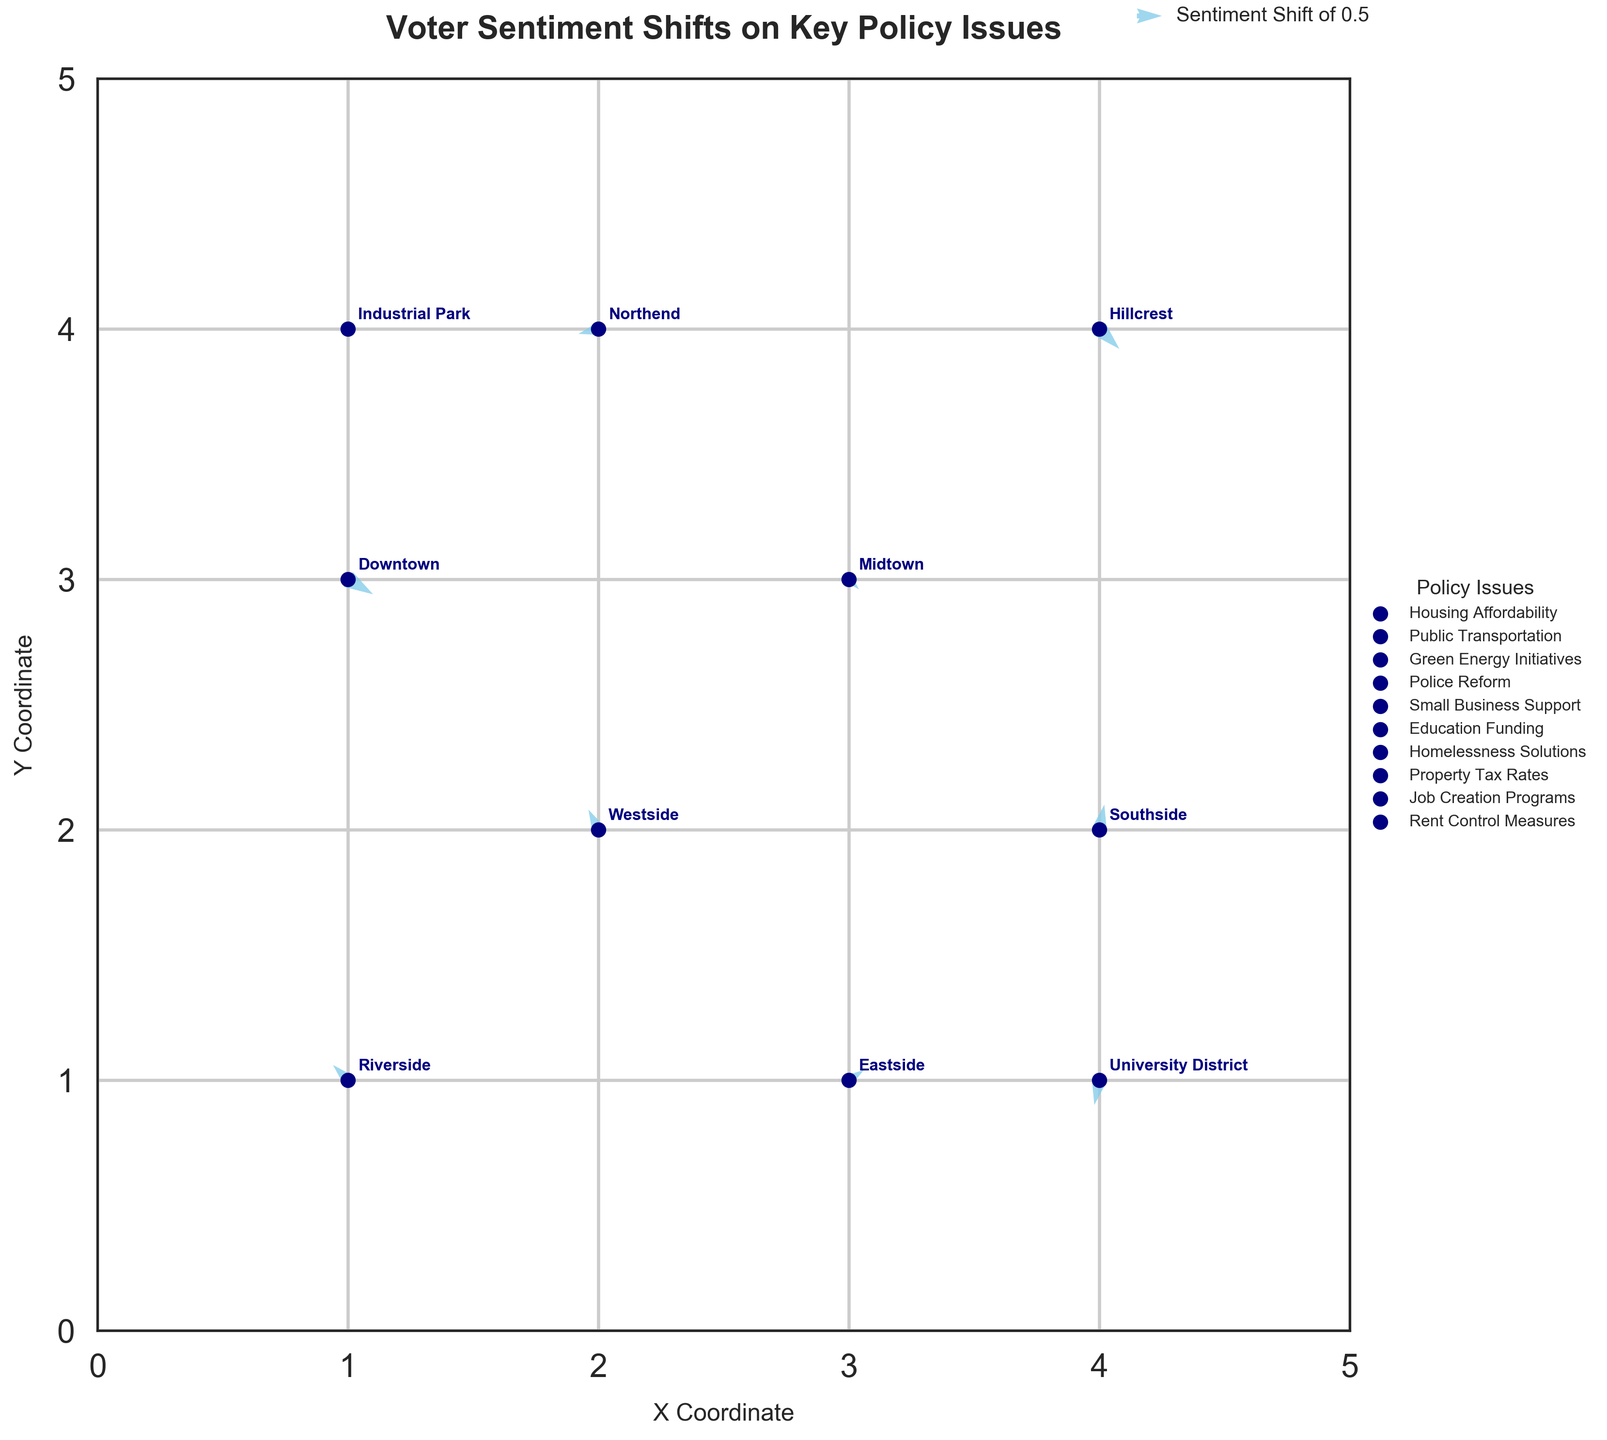What is the title of the figure? The title is typically displayed at the top of a plot to describe its subject or purpose. In this case, the title of the figure should be located at the top center of the plot in bold font.
Answer: Voter Sentiment Shifts on Key Policy Issues Which district shows a voter sentiment shift in favor of "Homelessness Solutions"? To determine this, locate the district associated with "Homelessness Solutions." Check the respective coordinates for any directional changes represented by the quiver. In this figure, Riverside is associated with "Homelessness Solutions".
Answer: Riverside How does voter sentiment in Northend shift with respect to Police Reform? First, identify the arrow originating from Northend. Since Northend is associated with Police Reform, follow the arrow to observe the direction and magnitude of change. The quiver shows a shift of (-0.4, -0.1), indicating a decrease in support.
Answer: Net decrease Between Downtown and Westside, which district has a greater negative shift in sentiment? Examine the arrows originating from Downtown and Westside. Both of these arrows have negative components, but you need to compare the magnitude of these vectors. Downtown's vector is (0.5, -0.3), and Westside's vector is (-0.2, 0.4). The negative components are -0.3 for Downtown and -0.2 for Westside, indicating Downtown has a greater negative shift.
Answer: Downtown What is the average sentiment shift magnitude in the positive X direction across all districts? Extract the X-components (U values) of sentiment shifts from all districts: 0.5, -0.2, 0.3, -0.4, 0.1, 0.2, -0.3, 0.4, 0.1, -0.1. Calculate the average of these values where they are positive: (0.5 + 0.3 + 0.1 + 0.2 + 0.4 + 0.1) / 6 = 1.6 / 6 = 0.267
Answer: 0.267 Which district has the most significant upward shift in sentiment? To find the district with the most substantial upward sentiment shift, look for the largest positive Y-component (V value) among all districts. Southside, with a V value of 0.5, represents the highest upward sentiment shift.
Answer: Southside How many districts are associated with shifts in "Housing Affordability"? Identify the district by checking the PolicyIssue label. In this figure, only the Downtown district is associated with "Housing Affordability." Ensure this policy issue is listed only once.
Answer: 1 Which policy issue experiences a southward movement in the University District? Identify the arrow representing the University District. Check the Y-component of the quiver originating there. Since "Rent Control Measures" is associated with this district and the arrow points southward (negative Y direction of -0.5), this policy issue experiences a southward movement.
Answer: Rent Control Measures Compare voter sentiment shifts in Eastside and Hillcrest regarding their directions. Are they opposite? Find the arrows originating from Eastside and Hillcrest. Note the direction and magnitude of vectors (0.3, 0.2) for Eastside and (0.4, -0.4) for Hillcrest. The directions are not entirely opposite; Eastside is shifting northeast while Hillcrest is shifting southeast.
Answer: No, they are not opposite What overall trend do you observe regarding voter sentiment shifts in green energy initiatives? Identify the district and direction of policy "Green Energy Initiatives" shown by the Eastside cluster. The sentiment shift direction is slightly northeast (positive U and V components), indicating a mild increase in support.
Answer: Mild increase in support 